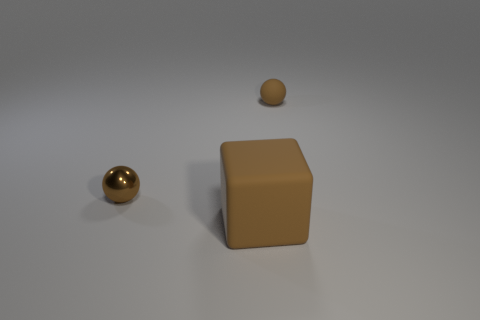Is the shape of the large thing the same as the tiny metallic object?
Ensure brevity in your answer.  No. There is a thing that is both to the right of the shiny ball and behind the big matte thing; what is its color?
Provide a short and direct response. Brown. There is a rubber object behind the brown metallic ball; does it have the same size as the object to the left of the big rubber block?
Your response must be concise. Yes. How many things are either objects that are in front of the brown matte sphere or rubber balls?
Offer a terse response. 3. Is the brown metallic object the same size as the brown matte ball?
Keep it short and to the point. Yes. What number of spheres are either big brown rubber objects or small matte objects?
Give a very brief answer. 1. What is the color of the rubber thing in front of the rubber object on the right side of the big brown rubber cube?
Your response must be concise. Brown. Is the number of tiny balls that are on the left side of the large brown object less than the number of things in front of the brown rubber sphere?
Your response must be concise. Yes. There is a shiny thing; is its size the same as the matte object in front of the brown shiny ball?
Offer a very short reply. No. What shape is the brown thing that is both right of the tiny metal sphere and to the left of the small brown matte thing?
Offer a very short reply. Cube. 